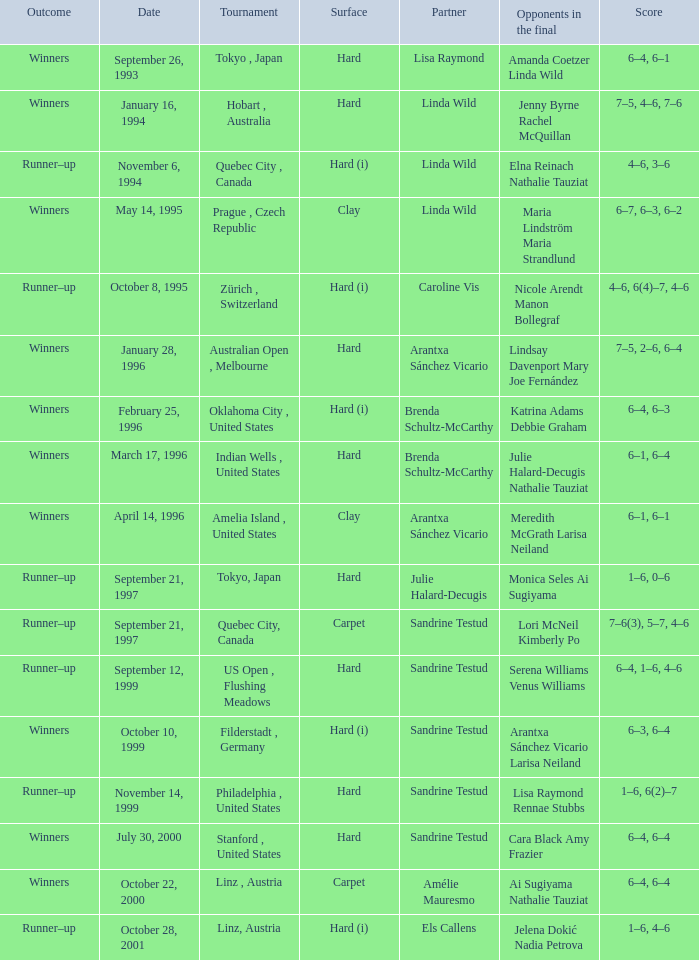Which surface had a partner of Sandrine Testud on November 14, 1999? Hard. 